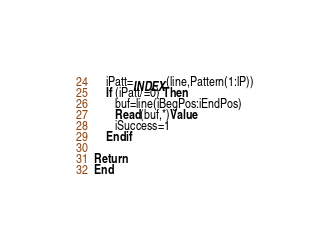Convert code to text. <code><loc_0><loc_0><loc_500><loc_500><_FORTRAN_>	iPatt=INDEX(line,Pattern(1:lP))
	If (iPatt/=0) Then
	   buf=line(iBegPos:iEndPos)
	   Read(buf,*)Value
       iSuccess=1
	Endif
	
Return
End

</code> 